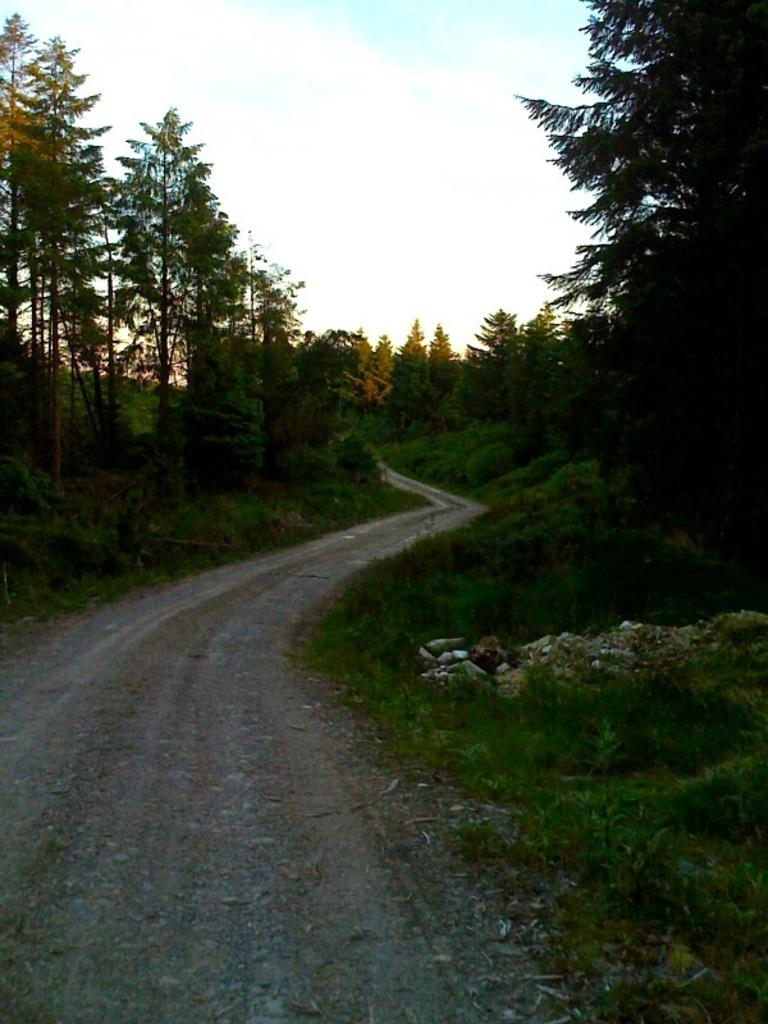What is visible at the top of the image? The sky is visible at the top of the image. What can be seen on either side of the road in the image? There are trees and grass on either side of the road in the image. How does the toad express regret in the image? There is no toad present in the image, and therefore no expression of regret can be observed. 